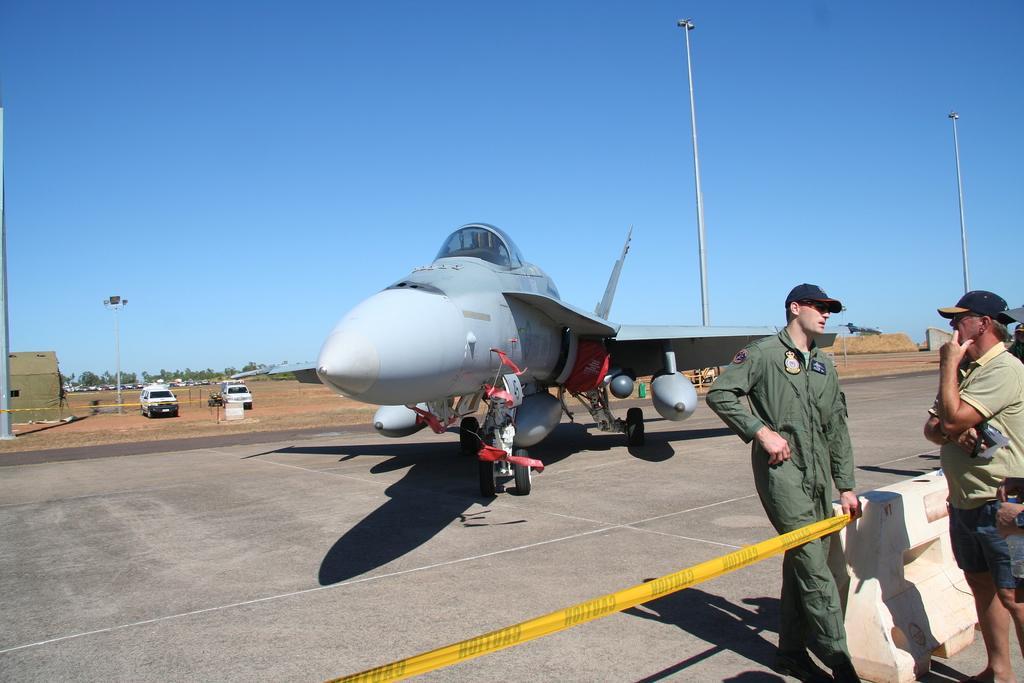Describe this image in one or two sentences. In this image I can see an aircraft. On the right side, I can see two people. I can see some vehicles. In the background, I can see the sky. 